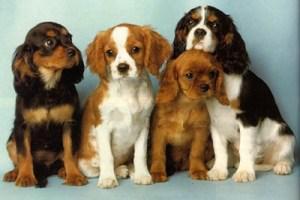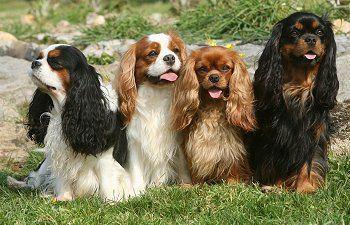The first image is the image on the left, the second image is the image on the right. Given the left and right images, does the statement "There are no less than six cocker spaniels" hold true? Answer yes or no. Yes. 